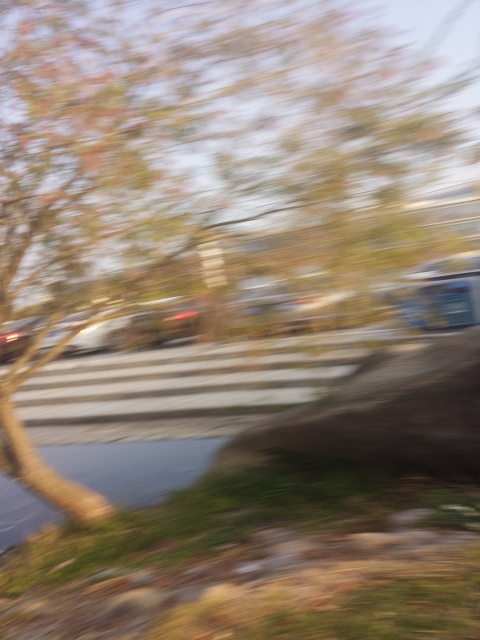Based on the blurring, what can we deduce about the settings used on the camera? The extent of the motion blur suggests that the camera's shutter speed was relatively slow, failing to freeze the moment instantly. This could be intentional to convey motion or accidental from an unsteady hand or a moving vehicle. A lower shutter speed allows more light to enter over the exposure time, which can be useful in lower light settings but risks capturing the motion as blur if the camera isn't stable or subjects move quickly. 